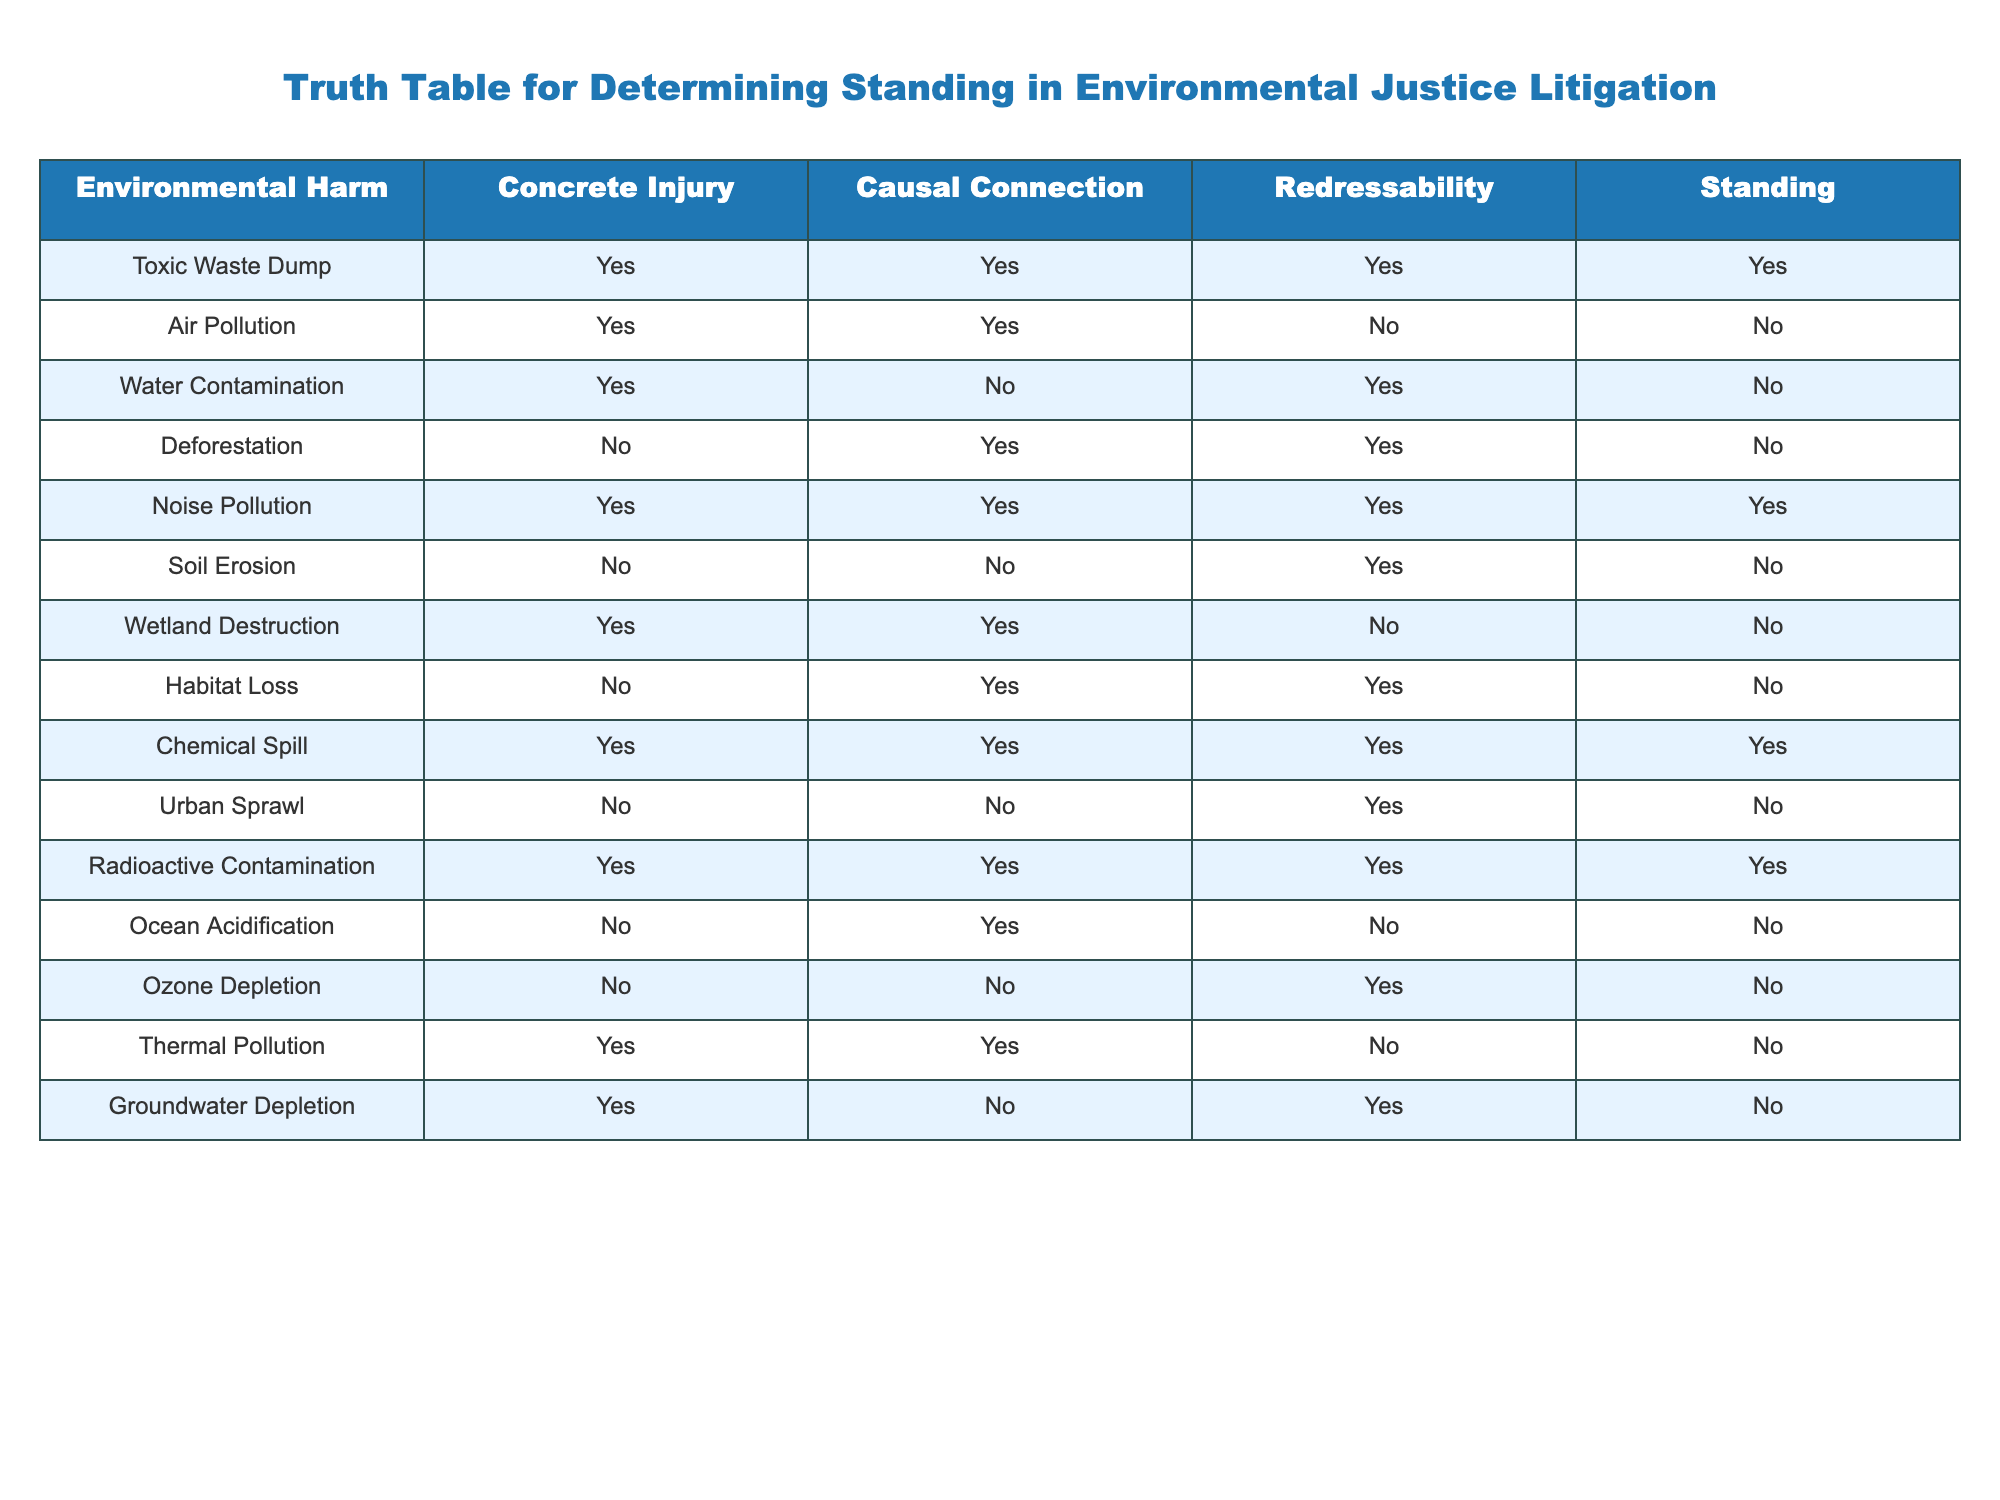What environmental harm is associated with a situation where there is concrete injury, causal connection, and redressability? According to the table, both "Toxic Waste Dump" and "Noise Pollution" have "Yes" for concrete injury, causal connection, and redressability.
Answer: Toxic Waste Dump, Noise Pollution Is there a case of water contamination that provides standing in litigation? The table indicates "Water Contamination" has a concrete injury, but it does not meet the criteria for redressability, resulting in "No" for standing.
Answer: No Which environmental harms lead to a determination of standing? The standing criteria are met in cases like "Toxic Waste Dump," "Noise Pollution," "Chemical Spill," and "Radioactive Contamination," all of which have "Yes" across the relevant columns.
Answer: Toxic Waste Dump, Noise Pollution, Chemical Spill, Radioactive Contamination How many cases in the table show a causal connection but not concrete injury? The only case with a causal connection and no concrete injury is "Deforestation." There’s also "Soil Erosion," but it has neither concrete injury nor causal connection. Therefore, there’s only one case specifically fitting the criteria.
Answer: 1 Is urban sprawl linked to any concrete injury in the table? The column for Urban Sprawl shows "No" for concrete injury, indicating that, despite potential environmental consequences, it does not demonstrate a specific injury that would grant standing.
Answer: No What is the total number of cases listed in the table that have redressability? By counting the "Yes" entries in the redressability column, we find "1" for Toxic Waste Dump, "No" for Air Pollution, and similarly for others—to find the total, we count the entries with "Yes." This yields a total of 4 cases.
Answer: 4 Are there any instances of air pollution that meet all four standing criteria in litigation? A review of the air pollution row shows it meets criteria for concrete injury and causal connection; however, it does not satisfy redressability criteria, leading to standing. The answer is therefore "No."
Answer: No Can you identify cases where there is environmental harm but no concrete injury? The cases for this condition include "Soil Erosion," "Deforestation," and "Urban Sprawl," where environmental harm is present, but there is no identified concrete injury.
Answer: Soil Erosion, Deforestation, Urban Sprawl Among the identified environmental threats, which have chemical impacts classified as "Yes" for standing? Examining the rows, "Toxic Waste Dump," "Chemical Spill," and "Radioactive Contamination" all demonstrate environmental threats with a complete standing assessment marked as "Yes."
Answer: Toxic Waste Dump, Chemical Spill, Radioactive Contamination 